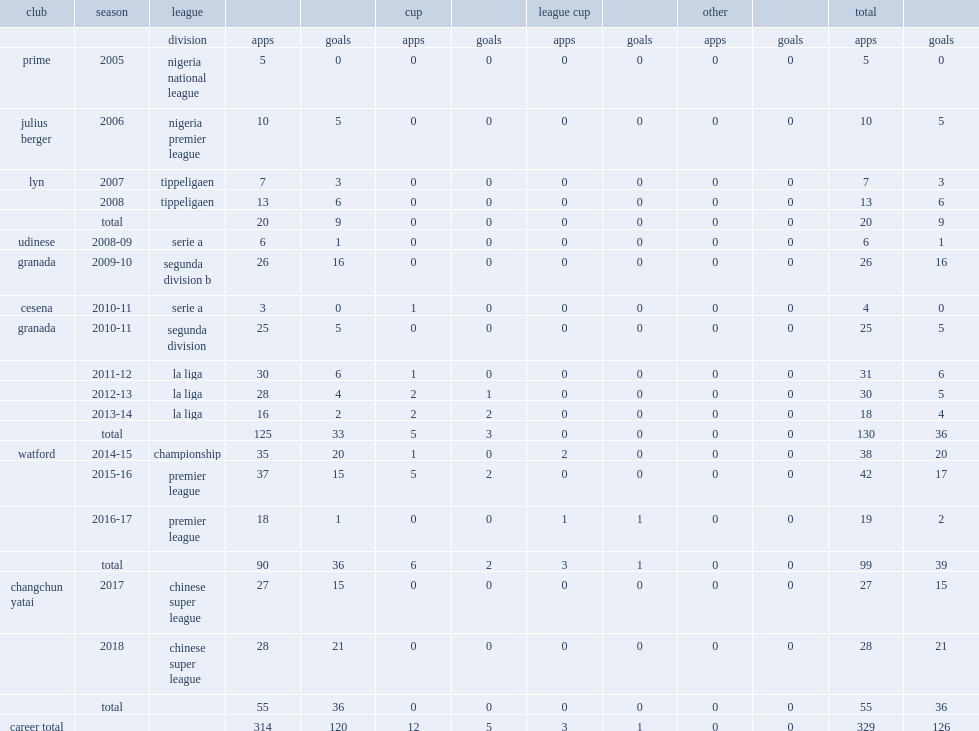Which club did ighalo play for in 2017? Changchun yatai. 